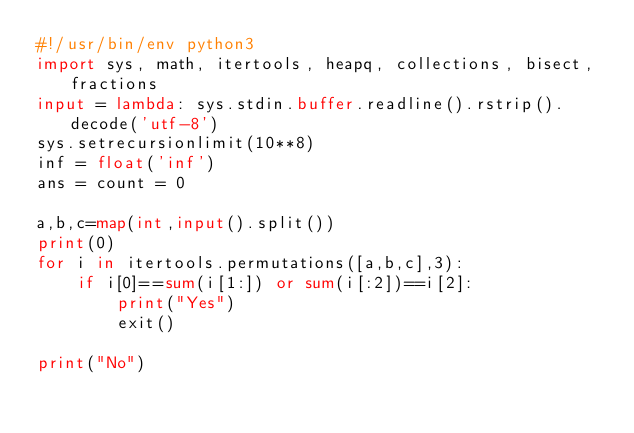<code> <loc_0><loc_0><loc_500><loc_500><_Python_>#!/usr/bin/env python3
import sys, math, itertools, heapq, collections, bisect, fractions
input = lambda: sys.stdin.buffer.readline().rstrip().decode('utf-8')
sys.setrecursionlimit(10**8)
inf = float('inf')
ans = count = 0

a,b,c=map(int,input().split())
print(0)
for i in itertools.permutations([a,b,c],3):
    if i[0]==sum(i[1:]) or sum(i[:2])==i[2]:
        print("Yes")
        exit()

print("No")</code> 